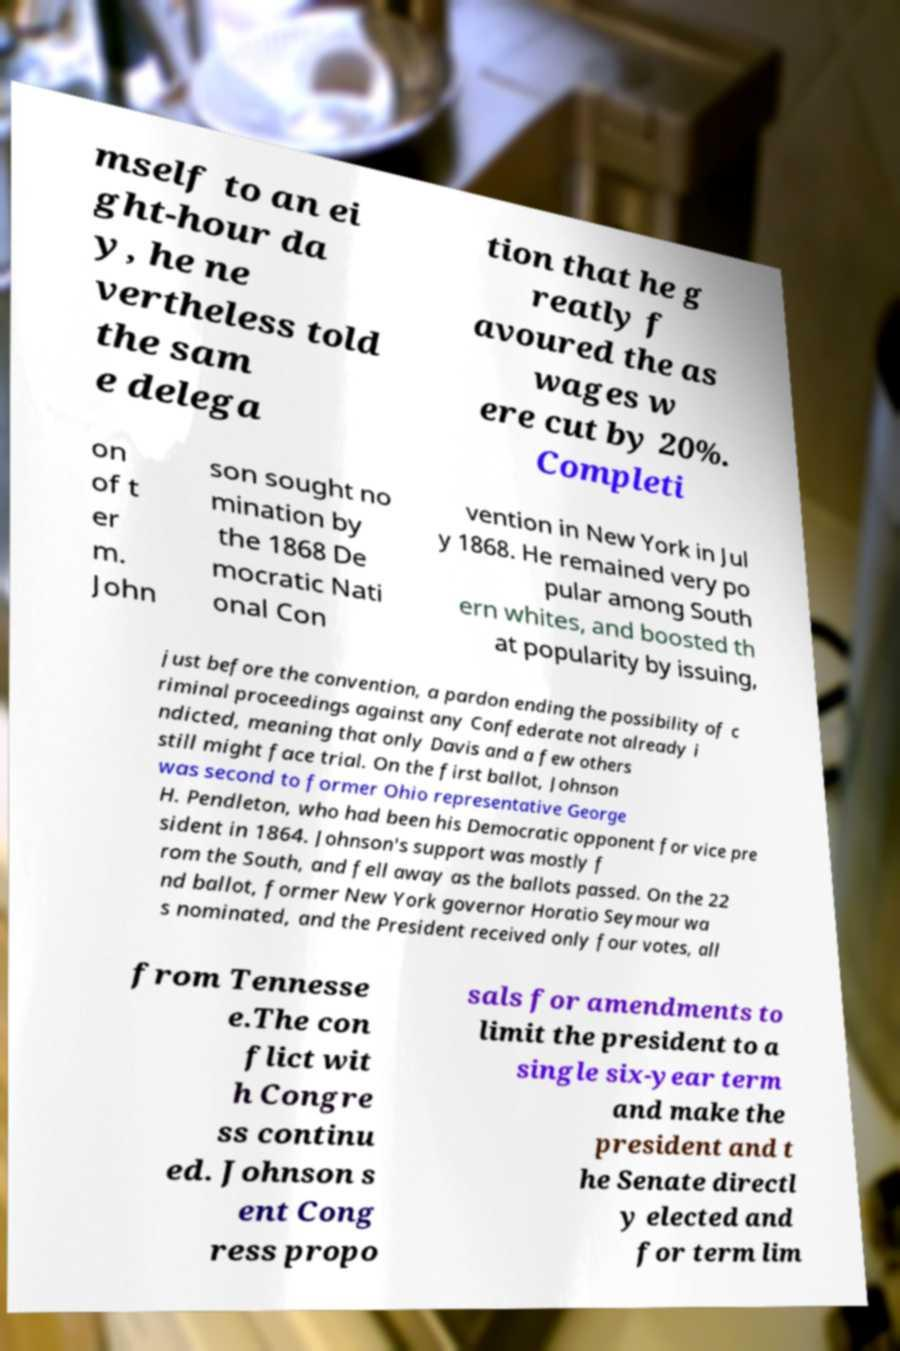What messages or text are displayed in this image? I need them in a readable, typed format. mself to an ei ght-hour da y, he ne vertheless told the sam e delega tion that he g reatly f avoured the as wages w ere cut by 20%. Completi on of t er m. John son sought no mination by the 1868 De mocratic Nati onal Con vention in New York in Jul y 1868. He remained very po pular among South ern whites, and boosted th at popularity by issuing, just before the convention, a pardon ending the possibility of c riminal proceedings against any Confederate not already i ndicted, meaning that only Davis and a few others still might face trial. On the first ballot, Johnson was second to former Ohio representative George H. Pendleton, who had been his Democratic opponent for vice pre sident in 1864. Johnson's support was mostly f rom the South, and fell away as the ballots passed. On the 22 nd ballot, former New York governor Horatio Seymour wa s nominated, and the President received only four votes, all from Tennesse e.The con flict wit h Congre ss continu ed. Johnson s ent Cong ress propo sals for amendments to limit the president to a single six-year term and make the president and t he Senate directl y elected and for term lim 